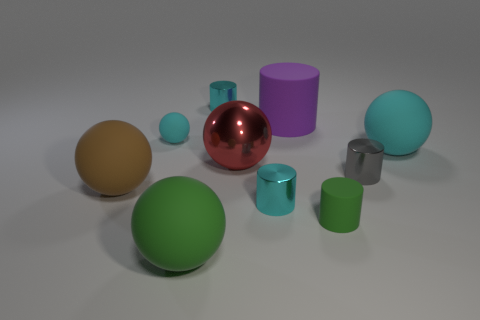How many cyan cylinders must be subtracted to get 1 cyan cylinders? 1 Subtract all large cyan balls. How many balls are left? 4 Subtract all brown balls. How many balls are left? 4 Subtract all yellow balls. Subtract all gray cylinders. How many balls are left? 5 Subtract 0 red cylinders. How many objects are left? 10 Subtract all big green metal cylinders. Subtract all red shiny things. How many objects are left? 9 Add 3 cylinders. How many cylinders are left? 8 Add 1 small green matte objects. How many small green matte objects exist? 2 